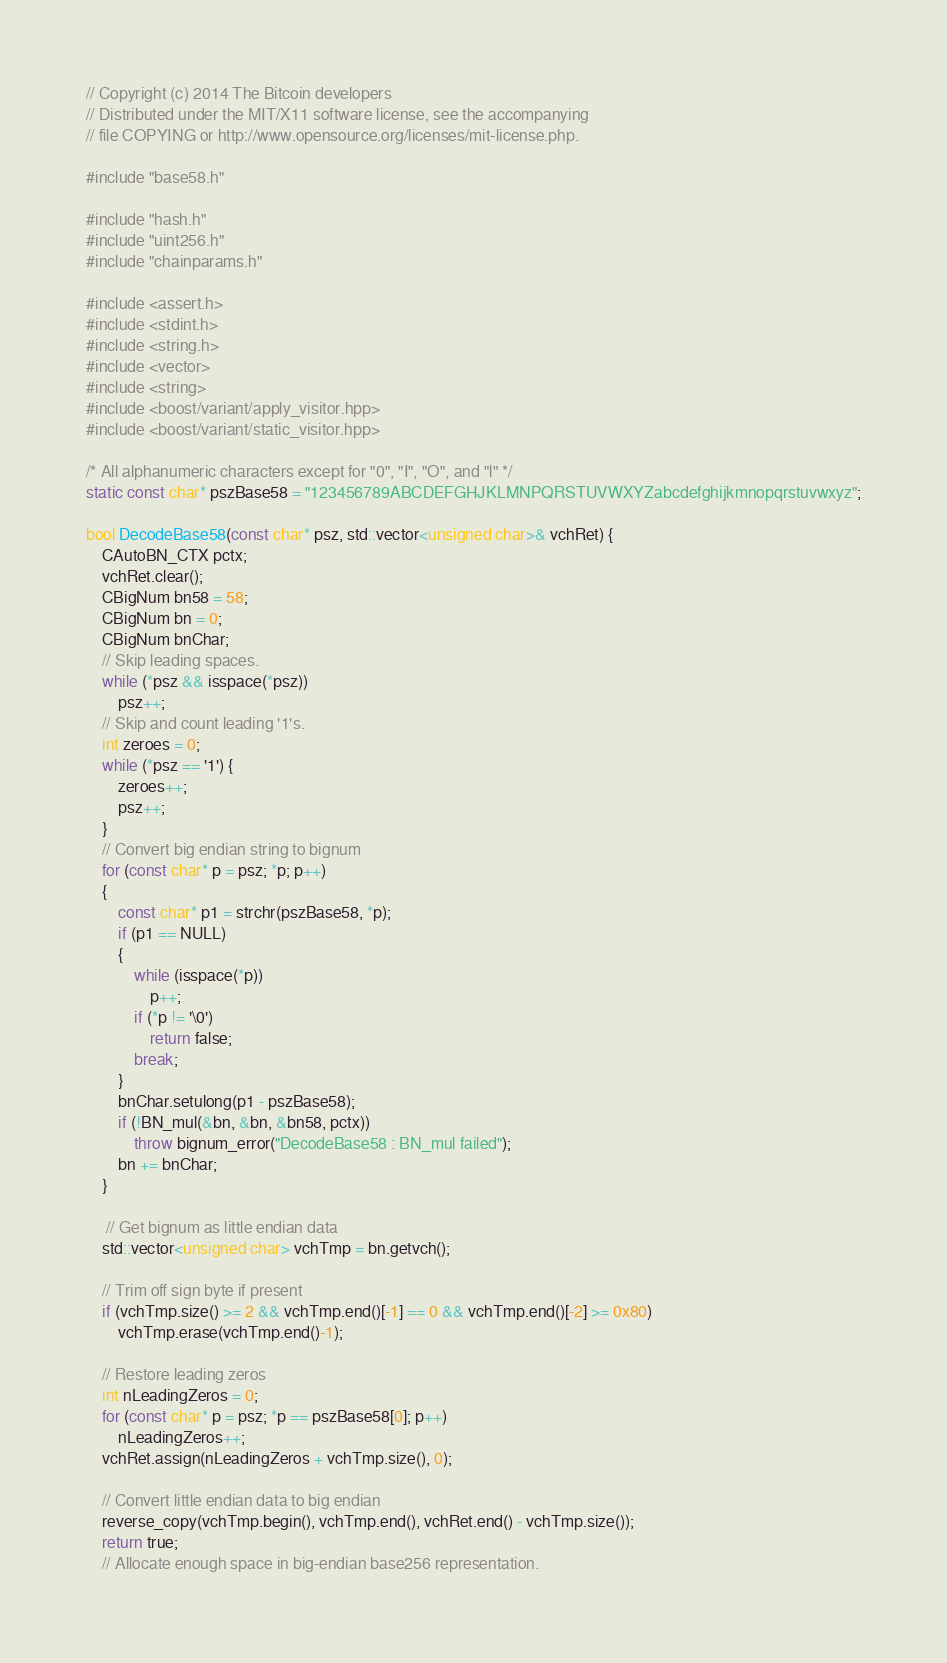<code> <loc_0><loc_0><loc_500><loc_500><_C++_>// Copyright (c) 2014 The Bitcoin developers
// Distributed under the MIT/X11 software license, see the accompanying
// file COPYING or http://www.opensource.org/licenses/mit-license.php.

#include "base58.h"

#include "hash.h"
#include "uint256.h"
#include "chainparams.h"

#include <assert.h>
#include <stdint.h>
#include <string.h>
#include <vector>
#include <string>
#include <boost/variant/apply_visitor.hpp>
#include <boost/variant/static_visitor.hpp>

/* All alphanumeric characters except for "0", "I", "O", and "l" */
static const char* pszBase58 = "123456789ABCDEFGHJKLMNPQRSTUVWXYZabcdefghijkmnopqrstuvwxyz";

bool DecodeBase58(const char* psz, std::vector<unsigned char>& vchRet) {
    CAutoBN_CTX pctx;
    vchRet.clear();
    CBigNum bn58 = 58;
    CBigNum bn = 0;
    CBigNum bnChar;
    // Skip leading spaces.
    while (*psz && isspace(*psz))
        psz++;
    // Skip and count leading '1's.
    int zeroes = 0;
    while (*psz == '1') {
        zeroes++;
        psz++;
    }
    // Convert big endian string to bignum
    for (const char* p = psz; *p; p++)
    {
        const char* p1 = strchr(pszBase58, *p);
        if (p1 == NULL)
        {
            while (isspace(*p))
                p++;
            if (*p != '\0')
                return false;
            break;
        }
        bnChar.setulong(p1 - pszBase58);
        if (!BN_mul(&bn, &bn, &bn58, pctx))
            throw bignum_error("DecodeBase58 : BN_mul failed");
        bn += bnChar;
    }

     // Get bignum as little endian data
    std::vector<unsigned char> vchTmp = bn.getvch();

    // Trim off sign byte if present
    if (vchTmp.size() >= 2 && vchTmp.end()[-1] == 0 && vchTmp.end()[-2] >= 0x80)
        vchTmp.erase(vchTmp.end()-1);

    // Restore leading zeros
    int nLeadingZeros = 0;
    for (const char* p = psz; *p == pszBase58[0]; p++)
        nLeadingZeros++;
    vchRet.assign(nLeadingZeros + vchTmp.size(), 0);

    // Convert little endian data to big endian
    reverse_copy(vchTmp.begin(), vchTmp.end(), vchRet.end() - vchTmp.size());
    return true;
    // Allocate enough space in big-endian base256 representation.</code> 